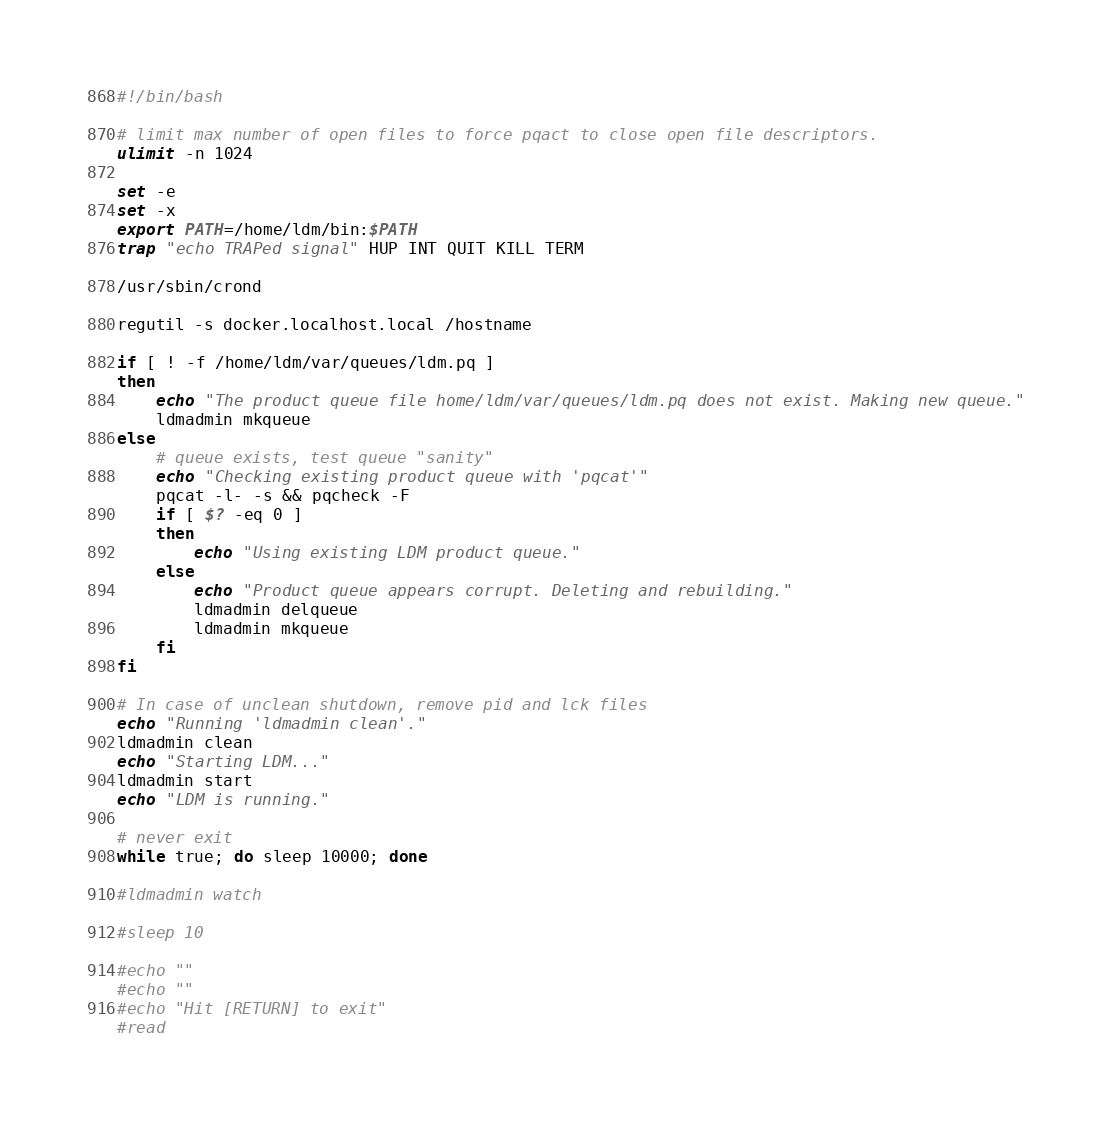Convert code to text. <code><loc_0><loc_0><loc_500><loc_500><_Bash_>#!/bin/bash

# limit max number of open files to force pqact to close open file descriptors.
ulimit -n 1024

set -e
set -x
export PATH=/home/ldm/bin:$PATH
trap "echo TRAPed signal" HUP INT QUIT KILL TERM

/usr/sbin/crond

regutil -s docker.localhost.local /hostname

if [ ! -f /home/ldm/var/queues/ldm.pq ]
then
    echo "The product queue file home/ldm/var/queues/ldm.pq does not exist. Making new queue."
    ldmadmin mkqueue
else
    # queue exists, test queue "sanity"
    echo "Checking existing product queue with 'pqcat'"
    pqcat -l- -s && pqcheck -F
    if [ $? -eq 0 ]
    then
        echo "Using existing LDM product queue."
    else
        echo "Product queue appears corrupt. Deleting and rebuilding."
        ldmadmin delqueue
        ldmadmin mkqueue
    fi
fi

# In case of unclean shutdown, remove pid and lck files
echo "Running 'ldmadmin clean'."
ldmadmin clean
echo "Starting LDM..."
ldmadmin start
echo "LDM is running."

# never exit
while true; do sleep 10000; done

#ldmadmin watch

#sleep 10

#echo ""
#echo ""
#echo "Hit [RETURN] to exit"
#read
</code> 